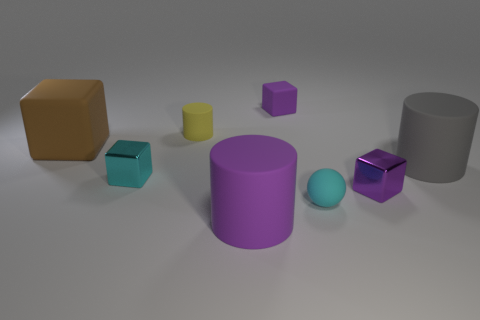Do the tiny yellow object and the small purple thing that is in front of the gray rubber object have the same shape?
Your response must be concise. No. How big is the brown thing?
Offer a terse response. Large. Are there fewer tiny rubber spheres behind the tiny cyan metal cube than big brown metallic balls?
Ensure brevity in your answer.  No. What number of cyan spheres are the same size as the cyan shiny thing?
Your response must be concise. 1. What is the shape of the big rubber thing that is the same color as the small matte block?
Keep it short and to the point. Cylinder. There is a big object on the right side of the purple matte cylinder; is its color the same as the matte cube in front of the small purple rubber thing?
Offer a very short reply. No. There is a cyan metal block; how many tiny matte cylinders are in front of it?
Keep it short and to the point. 0. There is a cube that is the same color as the tiny sphere; what is its size?
Make the answer very short. Small. Are there any other small objects that have the same shape as the purple metallic thing?
Make the answer very short. Yes. There is a matte cube that is the same size as the cyan ball; what is its color?
Provide a short and direct response. Purple. 